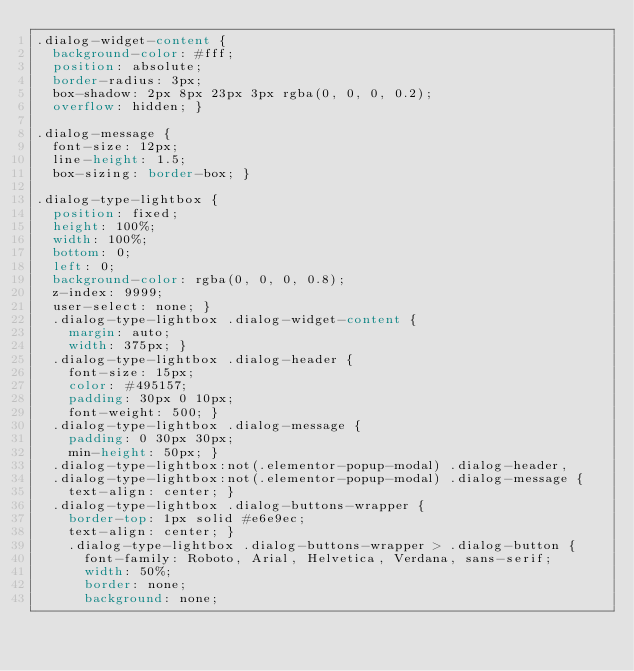Convert code to text. <code><loc_0><loc_0><loc_500><loc_500><_CSS_>.dialog-widget-content {
  background-color: #fff;
  position: absolute;
  border-radius: 3px;
  box-shadow: 2px 8px 23px 3px rgba(0, 0, 0, 0.2);
  overflow: hidden; }

.dialog-message {
  font-size: 12px;
  line-height: 1.5;
  box-sizing: border-box; }

.dialog-type-lightbox {
  position: fixed;
  height: 100%;
  width: 100%;
  bottom: 0;
  left: 0;
  background-color: rgba(0, 0, 0, 0.8);
  z-index: 9999;
  user-select: none; }
  .dialog-type-lightbox .dialog-widget-content {
    margin: auto;
    width: 375px; }
  .dialog-type-lightbox .dialog-header {
    font-size: 15px;
    color: #495157;
    padding: 30px 0 10px;
    font-weight: 500; }
  .dialog-type-lightbox .dialog-message {
    padding: 0 30px 30px;
    min-height: 50px; }
  .dialog-type-lightbox:not(.elementor-popup-modal) .dialog-header,
  .dialog-type-lightbox:not(.elementor-popup-modal) .dialog-message {
    text-align: center; }
  .dialog-type-lightbox .dialog-buttons-wrapper {
    border-top: 1px solid #e6e9ec;
    text-align: center; }
    .dialog-type-lightbox .dialog-buttons-wrapper > .dialog-button {
      font-family: Roboto, Arial, Helvetica, Verdana, sans-serif;
      width: 50%;
      border: none;
      background: none;</code> 